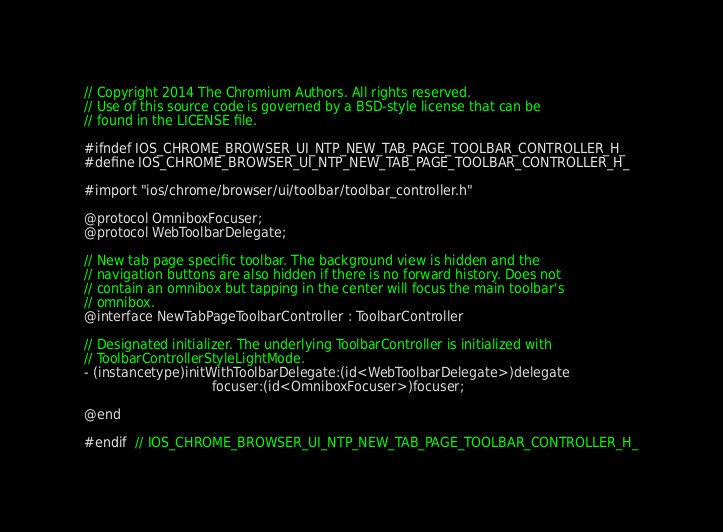<code> <loc_0><loc_0><loc_500><loc_500><_C_>// Copyright 2014 The Chromium Authors. All rights reserved.
// Use of this source code is governed by a BSD-style license that can be
// found in the LICENSE file.

#ifndef IOS_CHROME_BROWSER_UI_NTP_NEW_TAB_PAGE_TOOLBAR_CONTROLLER_H_
#define IOS_CHROME_BROWSER_UI_NTP_NEW_TAB_PAGE_TOOLBAR_CONTROLLER_H_

#import "ios/chrome/browser/ui/toolbar/toolbar_controller.h"

@protocol OmniboxFocuser;
@protocol WebToolbarDelegate;

// New tab page specific toolbar. The background view is hidden and the
// navigation buttons are also hidden if there is no forward history. Does not
// contain an omnibox but tapping in the center will focus the main toolbar's
// omnibox.
@interface NewTabPageToolbarController : ToolbarController

// Designated initializer. The underlying ToolbarController is initialized with
// ToolbarControllerStyleLightMode.
- (instancetype)initWithToolbarDelegate:(id<WebToolbarDelegate>)delegate
                                focuser:(id<OmniboxFocuser>)focuser;

@end

#endif  // IOS_CHROME_BROWSER_UI_NTP_NEW_TAB_PAGE_TOOLBAR_CONTROLLER_H_
</code> 